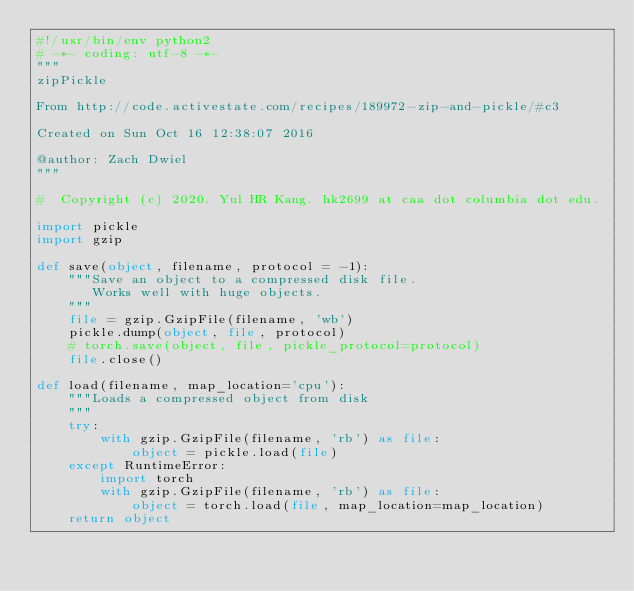<code> <loc_0><loc_0><loc_500><loc_500><_Python_>#!/usr/bin/env python2
# -*- coding: utf-8 -*-
"""
zipPickle

From http://code.activestate.com/recipes/189972-zip-and-pickle/#c3

Created on Sun Oct 16 12:38:07 2016

@author: Zach Dwiel
"""

#  Copyright (c) 2020. Yul HR Kang. hk2699 at caa dot columbia dot edu.

import pickle
import gzip

def save(object, filename, protocol = -1):
    """Save an object to a compressed disk file.
       Works well with huge objects.
    """
    file = gzip.GzipFile(filename, 'wb')
    pickle.dump(object, file, protocol)
    # torch.save(object, file, pickle_protocol=protocol)
    file.close()

def load(filename, map_location='cpu'):
    """Loads a compressed object from disk
    """
    try:
        with gzip.GzipFile(filename, 'rb') as file:
            object = pickle.load(file)
    except RuntimeError:
        import torch
        with gzip.GzipFile(filename, 'rb') as file:
            object = torch.load(file, map_location=map_location)
    return object</code> 